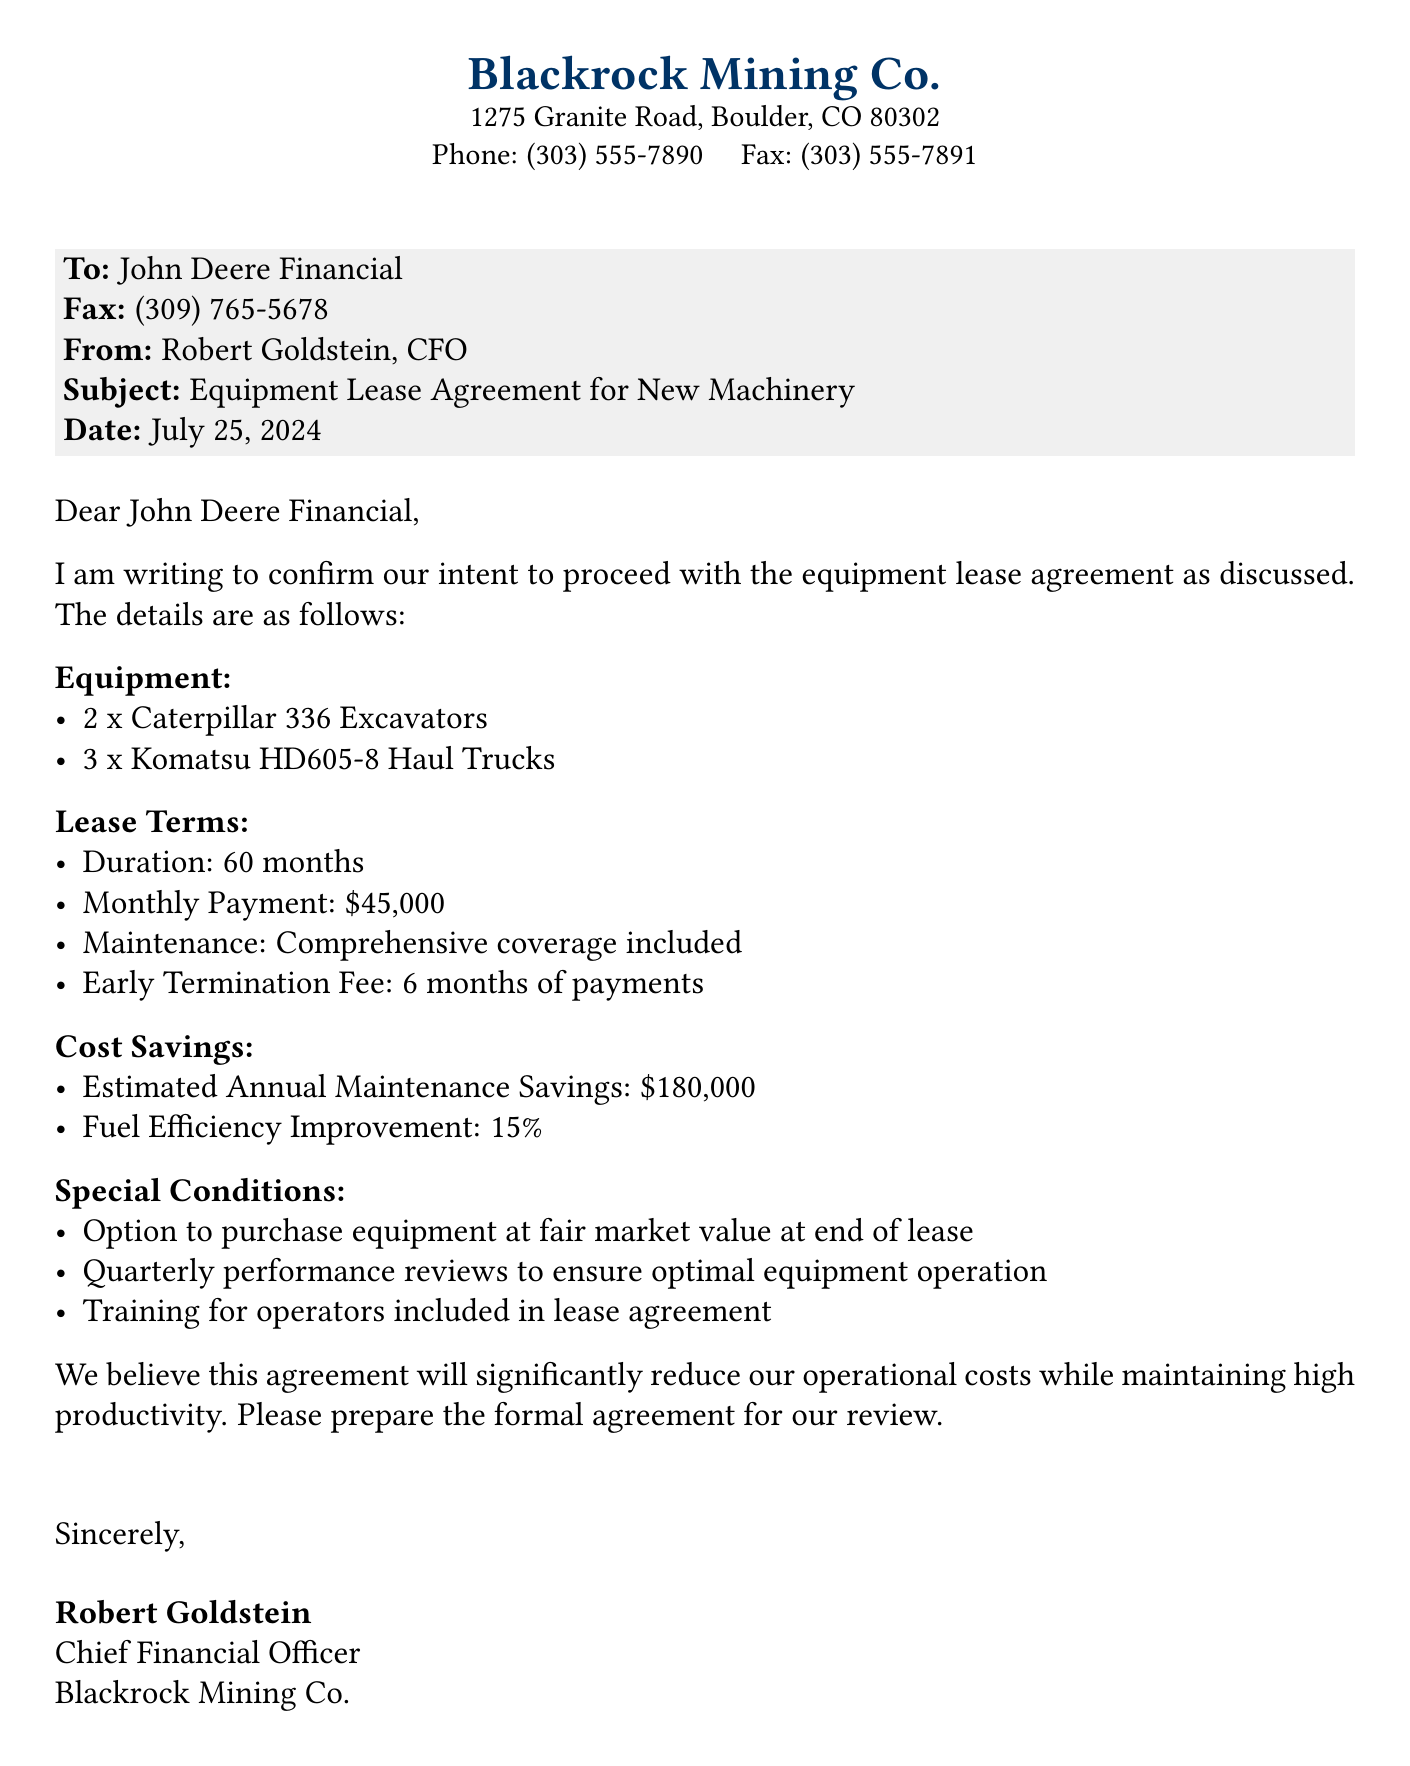What is the monthly payment? The monthly payment is specified in the lease terms as \$45,000.
Answer: \$45,000 How many Caterpillar 336 Excavators are included? The document lists the equipment included in the lease, stating "2 x Caterpillar 336 Excavators."
Answer: 2 What is the duration of the lease? The lease duration is mentioned as 60 months in the lease terms section.
Answer: 60 months What is the estimated annual maintenance savings? The document states an estimated annual maintenance savings of \$180,000.
Answer: \$180,000 What is included in the maintenance coverage? The lease terms state "Comprehensive coverage included" for maintenance.
Answer: Comprehensive coverage What option is provided at the end of the lease? The special conditions mention "Option to purchase equipment at fair market value at end of lease."
Answer: Option to purchase What percentage improvement is noted for fuel efficiency? The document specifies a "Fuel Efficiency Improvement: 15%."
Answer: 15% Who is the sender of the fax? The fax states that it is sent by Robert Goldstein, CFO of Blackrock Mining Co.
Answer: Robert Goldstein What is the early termination fee? The early termination fee is mentioned to be "6 months of payments" in the lease terms.
Answer: 6 months of payments 